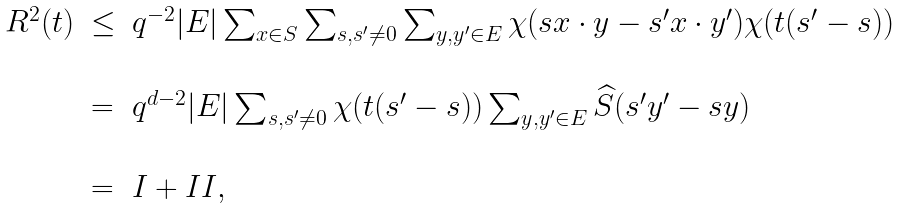<formula> <loc_0><loc_0><loc_500><loc_500>\begin{array} { l l l } R ^ { 2 } ( t ) & \leq & q ^ { - 2 } | E | \sum _ { x \in S } \sum _ { s , s ^ { \prime } \not = 0 } \sum _ { y , y ^ { \prime } \in E } \chi ( s x \cdot y - s ^ { \prime } x \cdot y ^ { \prime } ) \chi ( t ( s ^ { \prime } - s ) ) \\ \\ & = & q ^ { d - 2 } | E | \sum _ { s , s ^ { \prime } \not = 0 } \chi ( t ( s ^ { \prime } - s ) ) \sum _ { y , y ^ { \prime } \in E } \widehat { S } ( s ^ { \prime } y ^ { \prime } - s y ) \\ \\ & = & I + I I , \end{array}</formula> 